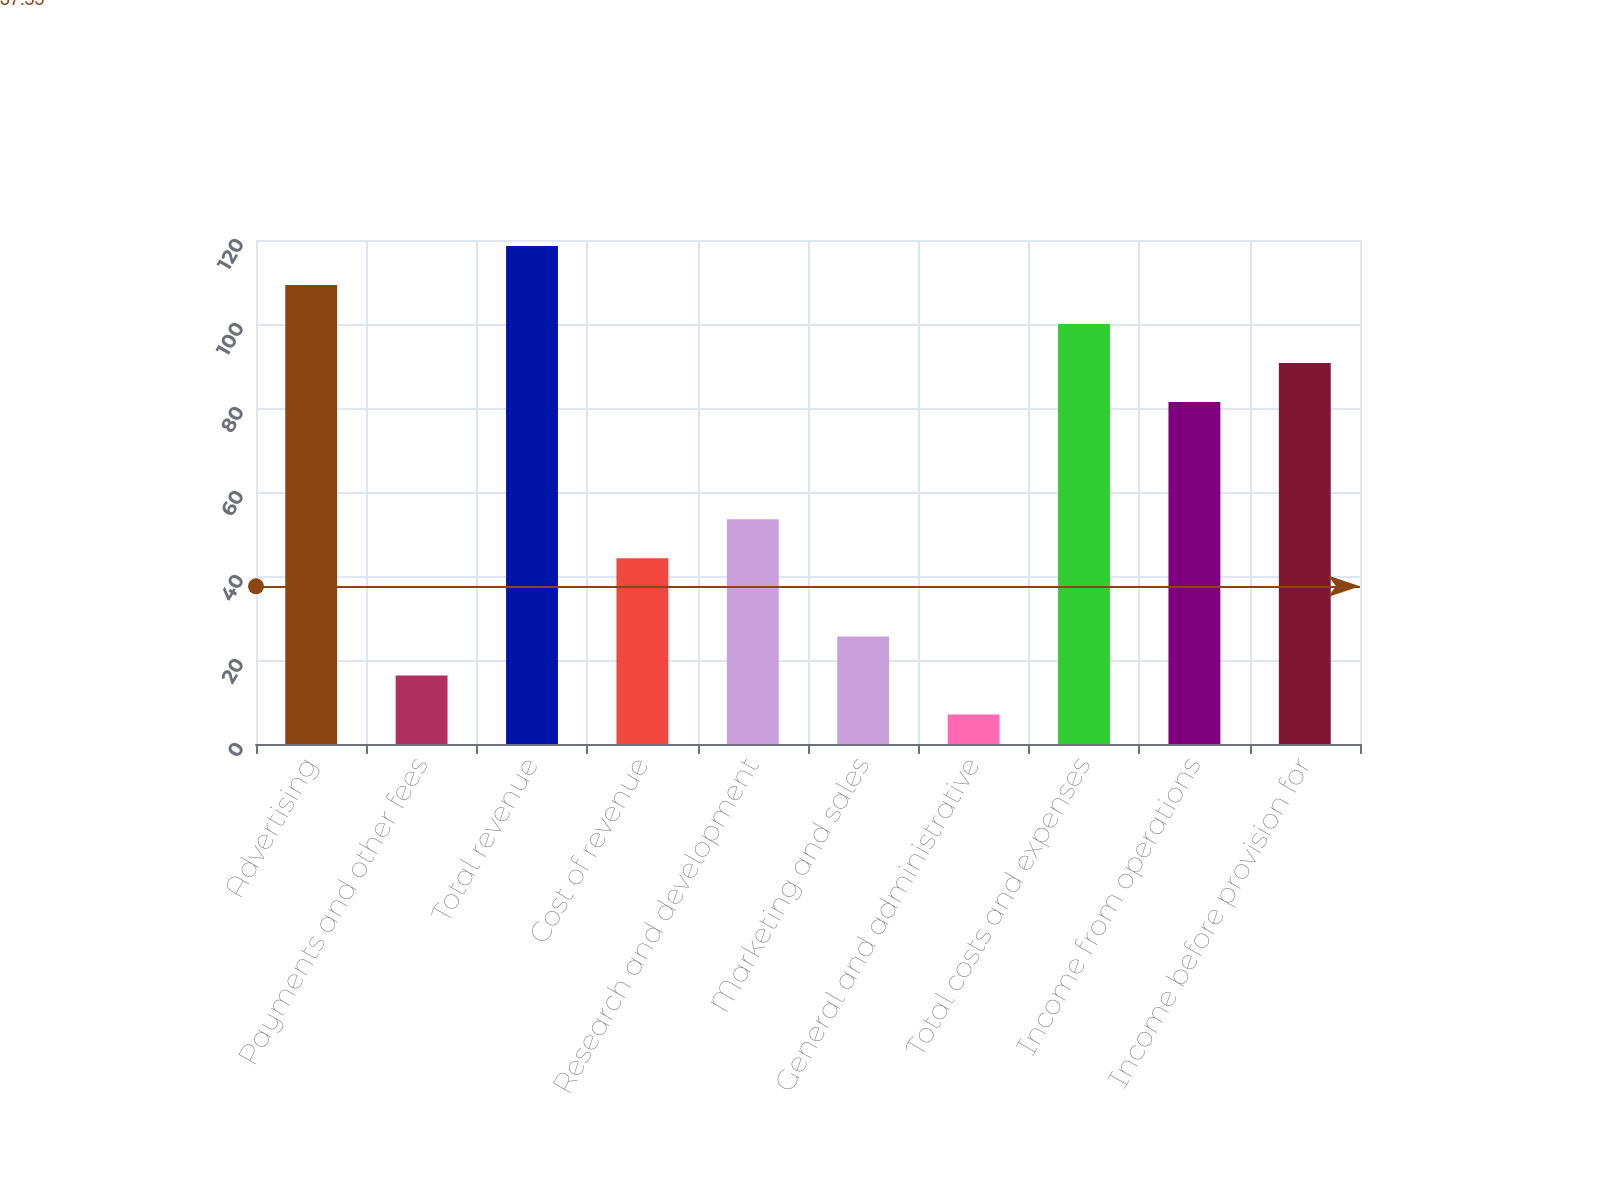Convert chart to OTSL. <chart><loc_0><loc_0><loc_500><loc_500><bar_chart><fcel>Advertising<fcel>Payments and other fees<fcel>Total revenue<fcel>Cost of revenue<fcel>Research and development<fcel>Marketing and sales<fcel>General and administrative<fcel>Total costs and expenses<fcel>Income from operations<fcel>Income before provision for<nl><fcel>109.3<fcel>16.3<fcel>118.6<fcel>44.2<fcel>53.5<fcel>25.6<fcel>7<fcel>100<fcel>81.4<fcel>90.7<nl></chart> 